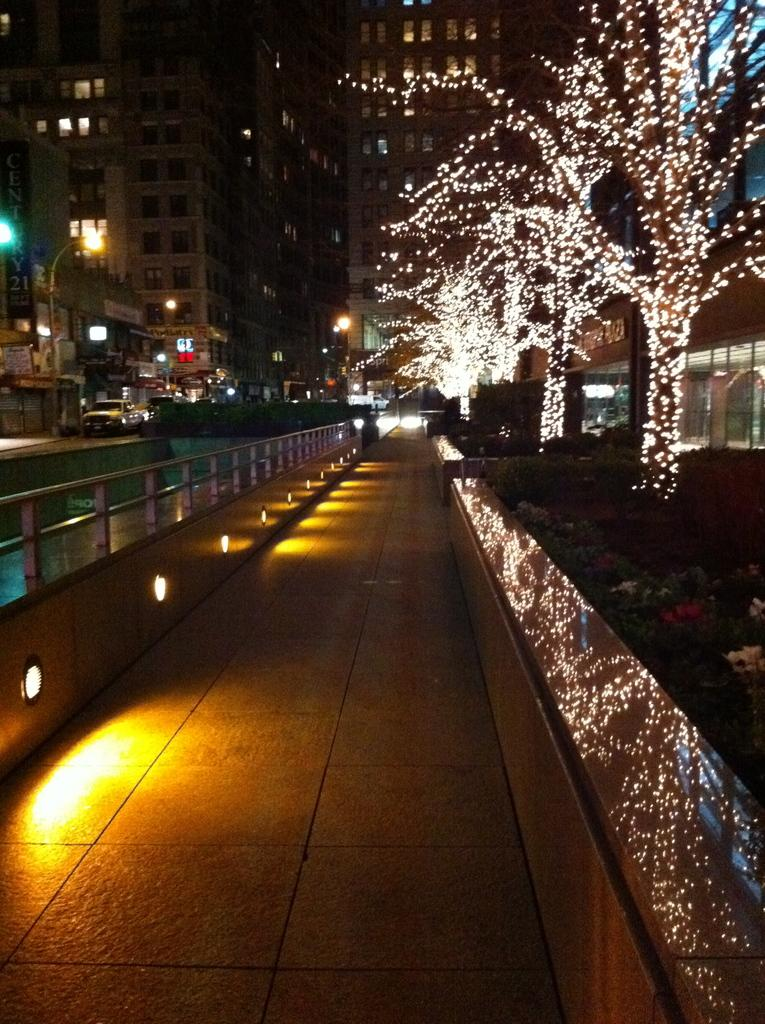What is located in the center of the image? There is a sidewalk in the center of the image. What can be seen in the distance behind the sidewalk? There are buildings in the background of the image. What additional features are present in the background? Trees with lights are present in the background of the image. What else is visible in the background? There are vehicles on the road in the background of the image. What type of wound can be seen on the prison guard in the image? There is no prison or prison guard present in the image. 